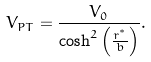<formula> <loc_0><loc_0><loc_500><loc_500>V _ { P T } = \frac { V _ { 0 } } { \cosh ^ { 2 } \left ( \frac { r ^ { ^ { * } } } { b } \right ) } .</formula> 